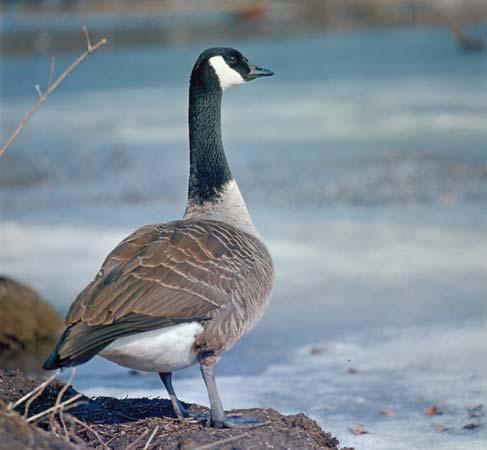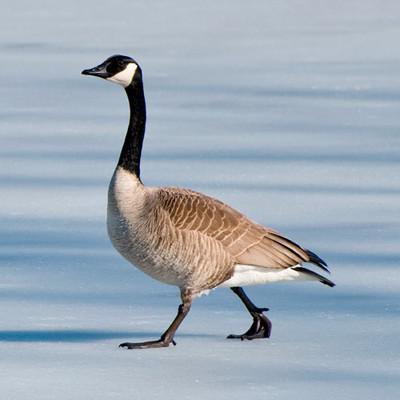The first image is the image on the left, the second image is the image on the right. Given the left and right images, does the statement "the bird on the left faces right and the bird on the right faces left" hold true? Answer yes or no. Yes. 